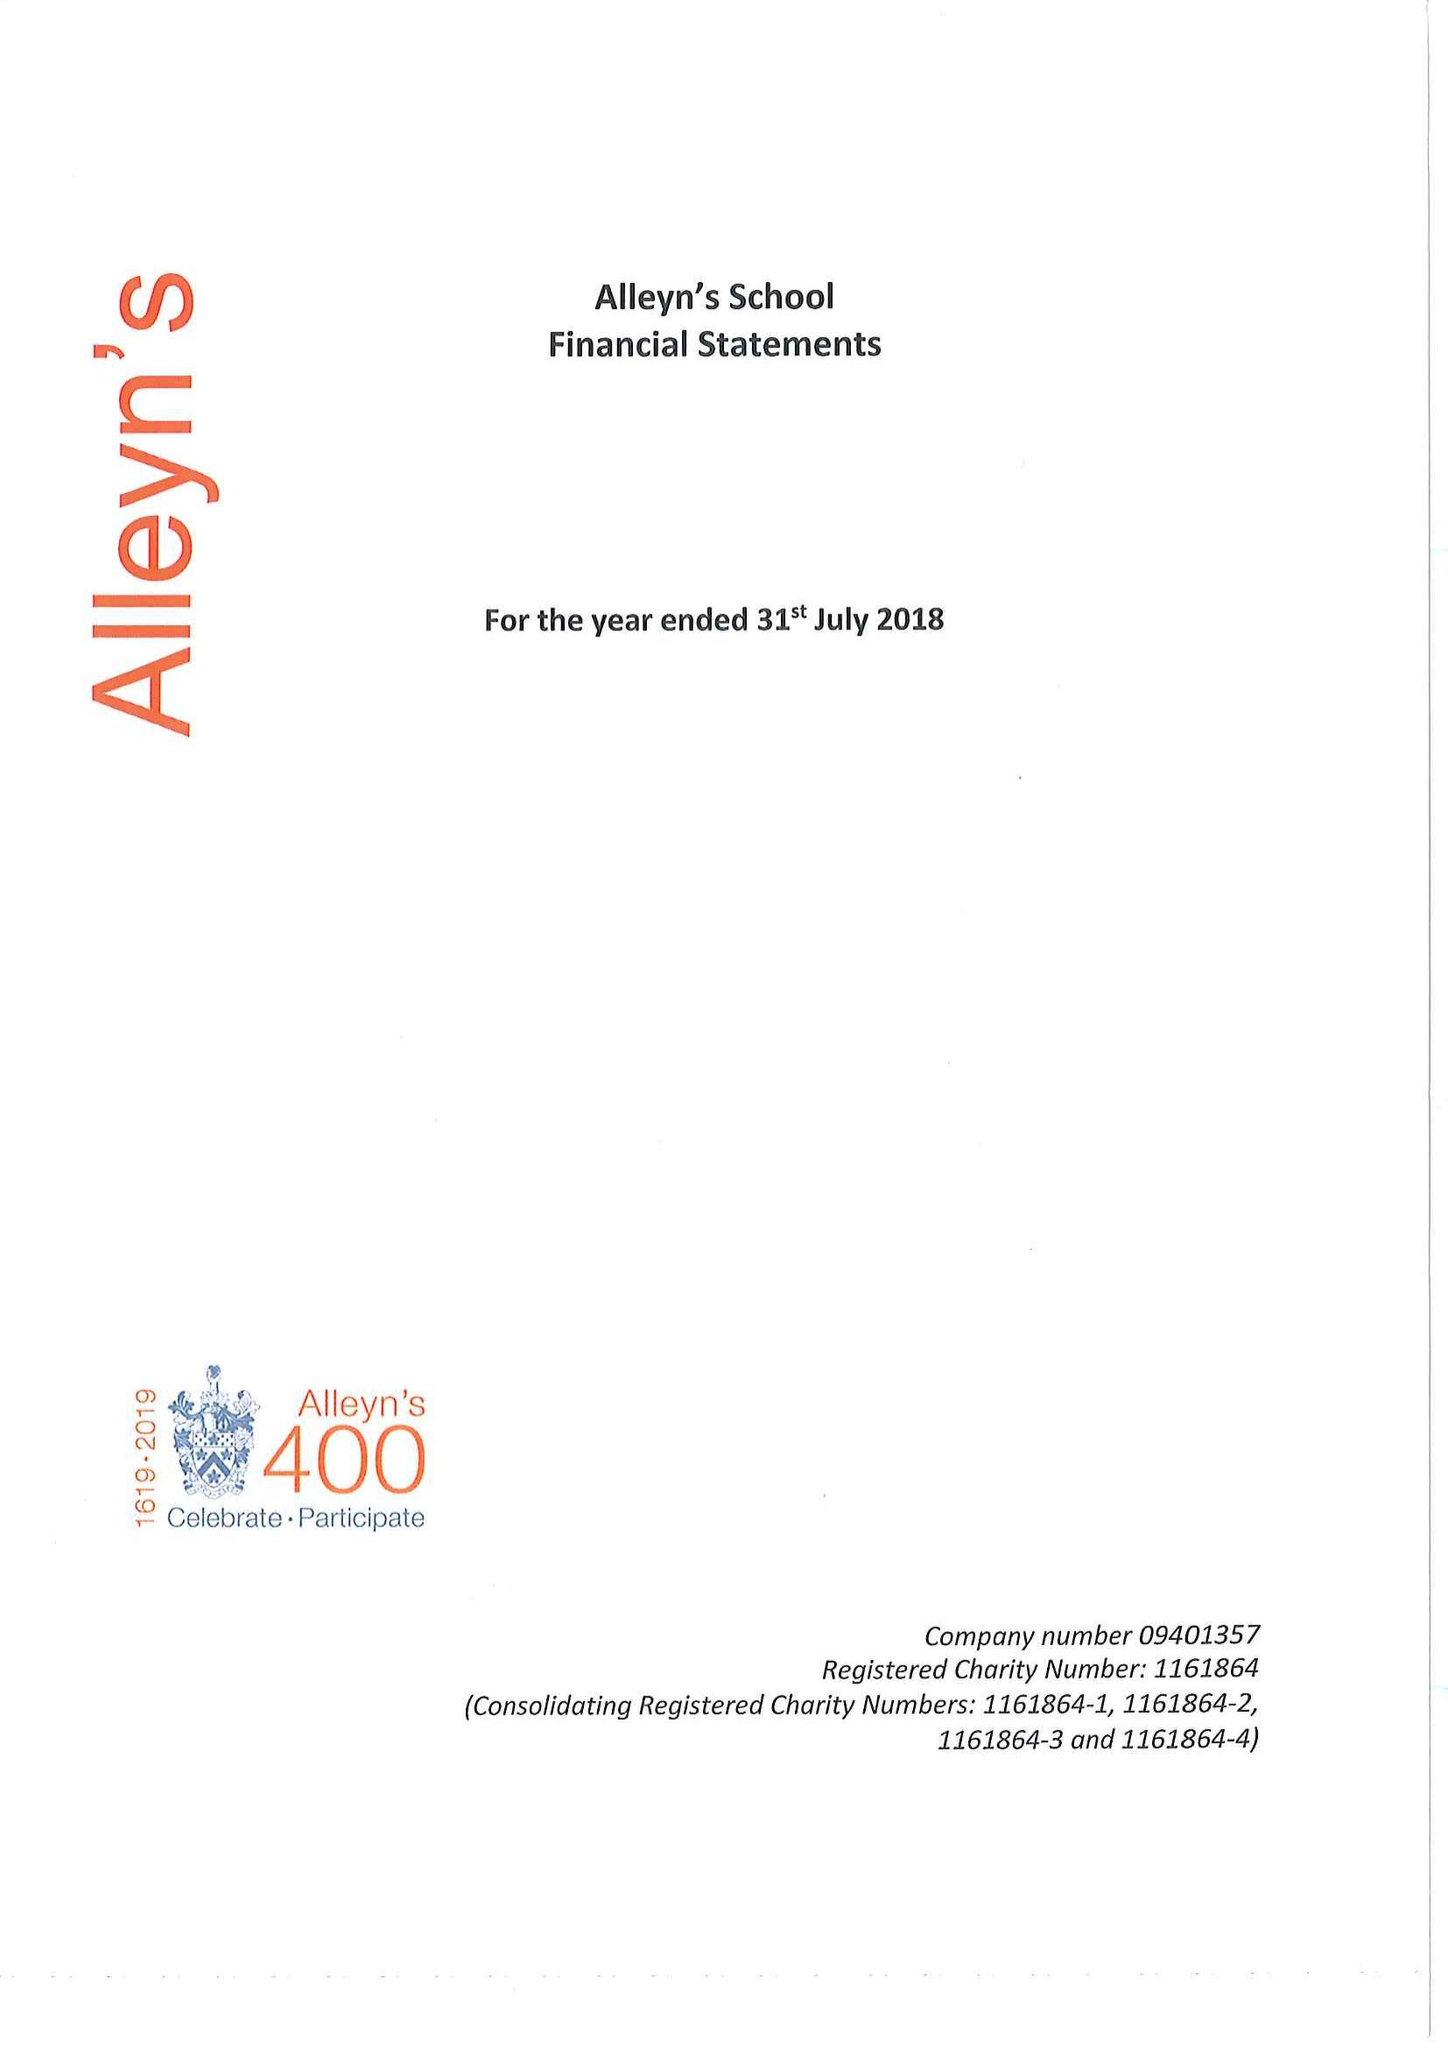What is the value for the charity_number?
Answer the question using a single word or phrase. 1161864 